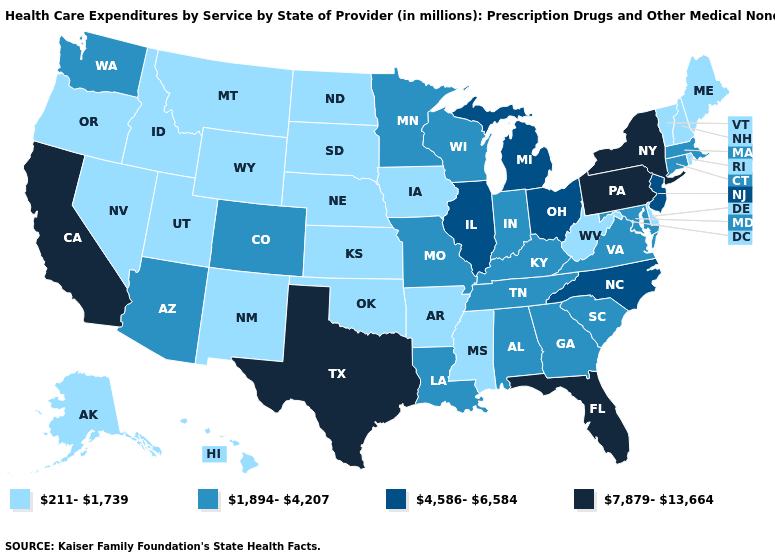Name the states that have a value in the range 1,894-4,207?
Write a very short answer. Alabama, Arizona, Colorado, Connecticut, Georgia, Indiana, Kentucky, Louisiana, Maryland, Massachusetts, Minnesota, Missouri, South Carolina, Tennessee, Virginia, Washington, Wisconsin. Among the states that border Idaho , does Wyoming have the lowest value?
Give a very brief answer. Yes. Is the legend a continuous bar?
Short answer required. No. Does Utah have a lower value than Kentucky?
Keep it brief. Yes. Which states hav the highest value in the Northeast?
Write a very short answer. New York, Pennsylvania. Does Arkansas have a lower value than Delaware?
Answer briefly. No. What is the value of Washington?
Concise answer only. 1,894-4,207. Which states hav the highest value in the West?
Keep it brief. California. Does New York have the highest value in the Northeast?
Quick response, please. Yes. Does the first symbol in the legend represent the smallest category?
Concise answer only. Yes. Among the states that border Vermont , which have the highest value?
Be succinct. New York. What is the value of Oklahoma?
Be succinct. 211-1,739. What is the value of New Hampshire?
Be succinct. 211-1,739. Among the states that border South Carolina , which have the lowest value?
Quick response, please. Georgia. Does Alaska have the highest value in the West?
Give a very brief answer. No. 